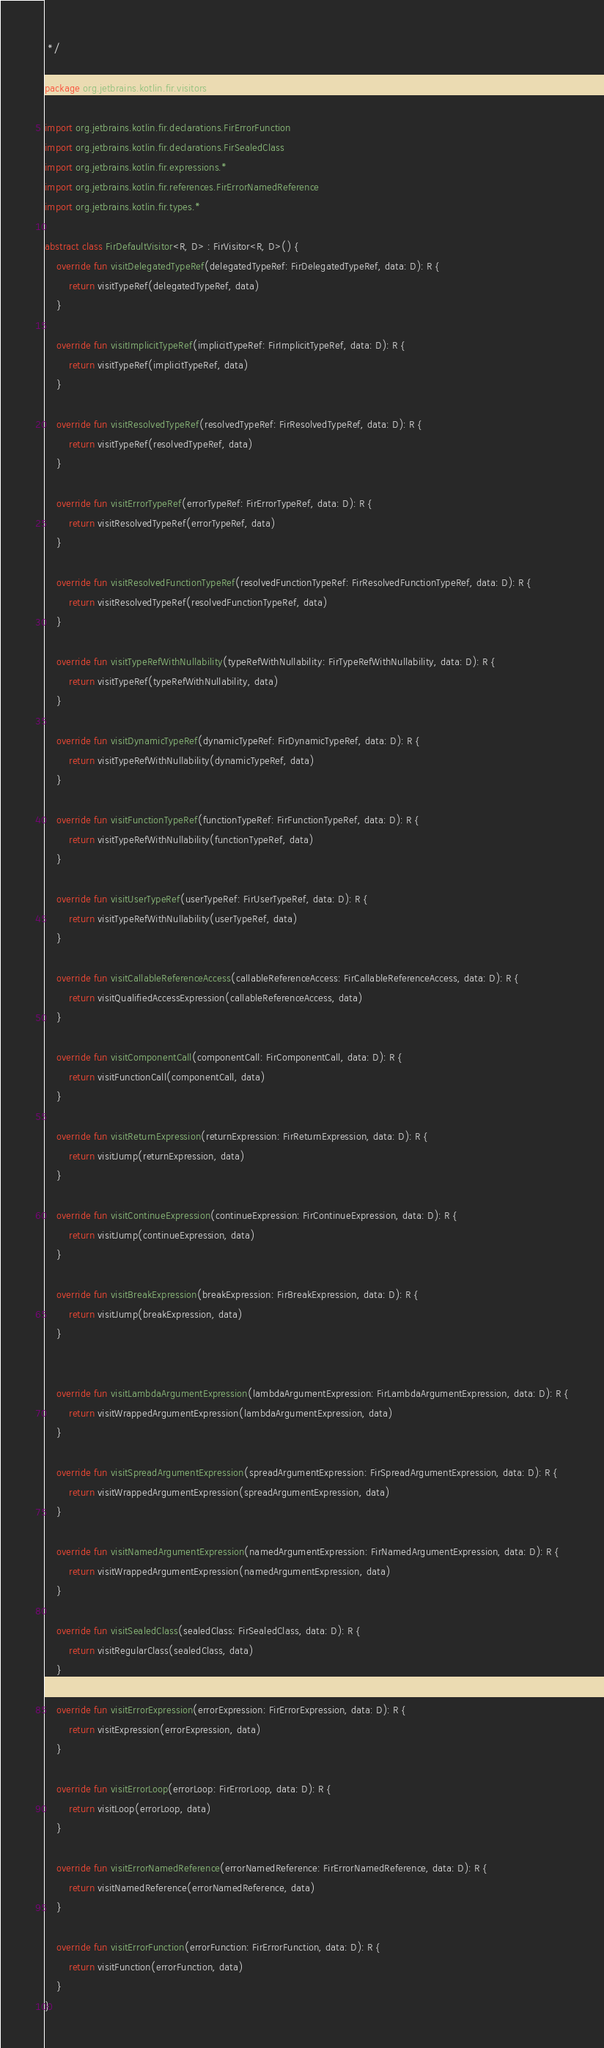<code> <loc_0><loc_0><loc_500><loc_500><_Kotlin_> */

package org.jetbrains.kotlin.fir.visitors

import org.jetbrains.kotlin.fir.declarations.FirErrorFunction
import org.jetbrains.kotlin.fir.declarations.FirSealedClass
import org.jetbrains.kotlin.fir.expressions.*
import org.jetbrains.kotlin.fir.references.FirErrorNamedReference
import org.jetbrains.kotlin.fir.types.*

abstract class FirDefaultVisitor<R, D> : FirVisitor<R, D>() {
    override fun visitDelegatedTypeRef(delegatedTypeRef: FirDelegatedTypeRef, data: D): R {
        return visitTypeRef(delegatedTypeRef, data)
    }

    override fun visitImplicitTypeRef(implicitTypeRef: FirImplicitTypeRef, data: D): R {
        return visitTypeRef(implicitTypeRef, data)
    }

    override fun visitResolvedTypeRef(resolvedTypeRef: FirResolvedTypeRef, data: D): R {
        return visitTypeRef(resolvedTypeRef, data)
    }

    override fun visitErrorTypeRef(errorTypeRef: FirErrorTypeRef, data: D): R {
        return visitResolvedTypeRef(errorTypeRef, data)
    }

    override fun visitResolvedFunctionTypeRef(resolvedFunctionTypeRef: FirResolvedFunctionTypeRef, data: D): R {
        return visitResolvedTypeRef(resolvedFunctionTypeRef, data)
    }

    override fun visitTypeRefWithNullability(typeRefWithNullability: FirTypeRefWithNullability, data: D): R {
        return visitTypeRef(typeRefWithNullability, data)
    }

    override fun visitDynamicTypeRef(dynamicTypeRef: FirDynamicTypeRef, data: D): R {
        return visitTypeRefWithNullability(dynamicTypeRef, data)
    }

    override fun visitFunctionTypeRef(functionTypeRef: FirFunctionTypeRef, data: D): R {
        return visitTypeRefWithNullability(functionTypeRef, data)
    }

    override fun visitUserTypeRef(userTypeRef: FirUserTypeRef, data: D): R {
        return visitTypeRefWithNullability(userTypeRef, data)
    }

    override fun visitCallableReferenceAccess(callableReferenceAccess: FirCallableReferenceAccess, data: D): R {
        return visitQualifiedAccessExpression(callableReferenceAccess, data)
    }

    override fun visitComponentCall(componentCall: FirComponentCall, data: D): R {
        return visitFunctionCall(componentCall, data)
    }

    override fun visitReturnExpression(returnExpression: FirReturnExpression, data: D): R {
        return visitJump(returnExpression, data)
    }

    override fun visitContinueExpression(continueExpression: FirContinueExpression, data: D): R {
        return visitJump(continueExpression, data)
    }

    override fun visitBreakExpression(breakExpression: FirBreakExpression, data: D): R {
        return visitJump(breakExpression, data)
    }


    override fun visitLambdaArgumentExpression(lambdaArgumentExpression: FirLambdaArgumentExpression, data: D): R {
        return visitWrappedArgumentExpression(lambdaArgumentExpression, data)
    }

    override fun visitSpreadArgumentExpression(spreadArgumentExpression: FirSpreadArgumentExpression, data: D): R {
        return visitWrappedArgumentExpression(spreadArgumentExpression, data)
    }

    override fun visitNamedArgumentExpression(namedArgumentExpression: FirNamedArgumentExpression, data: D): R {
        return visitWrappedArgumentExpression(namedArgumentExpression, data)
    }

    override fun visitSealedClass(sealedClass: FirSealedClass, data: D): R {
        return visitRegularClass(sealedClass, data)
    }

    override fun visitErrorExpression(errorExpression: FirErrorExpression, data: D): R {
        return visitExpression(errorExpression, data)
    }

    override fun visitErrorLoop(errorLoop: FirErrorLoop, data: D): R {
        return visitLoop(errorLoop, data)
    }

    override fun visitErrorNamedReference(errorNamedReference: FirErrorNamedReference, data: D): R {
        return visitNamedReference(errorNamedReference, data)
    }

    override fun visitErrorFunction(errorFunction: FirErrorFunction, data: D): R {
        return visitFunction(errorFunction, data)
    }
}

</code> 